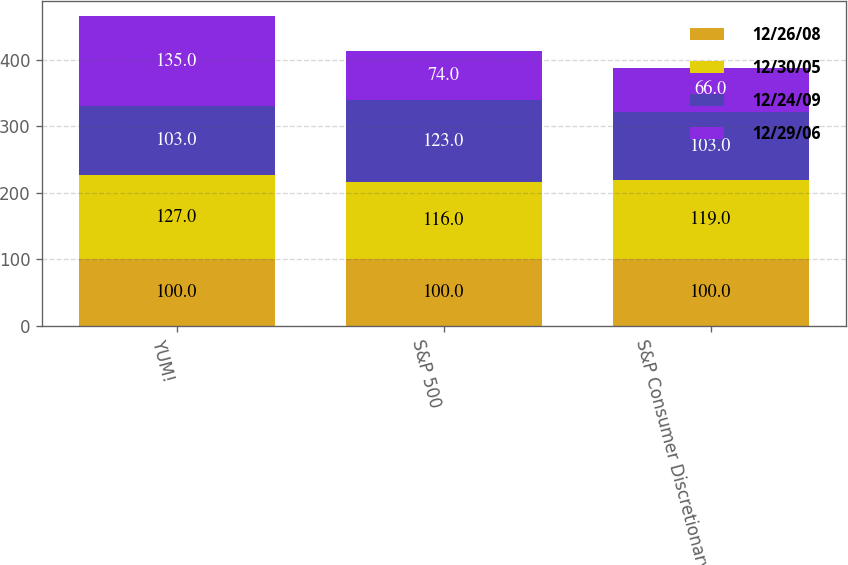<chart> <loc_0><loc_0><loc_500><loc_500><stacked_bar_chart><ecel><fcel>YUM!<fcel>S&P 500<fcel>S&P Consumer Discretionary<nl><fcel>12/26/08<fcel>100<fcel>100<fcel>100<nl><fcel>12/30/05<fcel>127<fcel>116<fcel>119<nl><fcel>12/24/09<fcel>103<fcel>123<fcel>103<nl><fcel>12/29/06<fcel>135<fcel>74<fcel>66<nl></chart> 